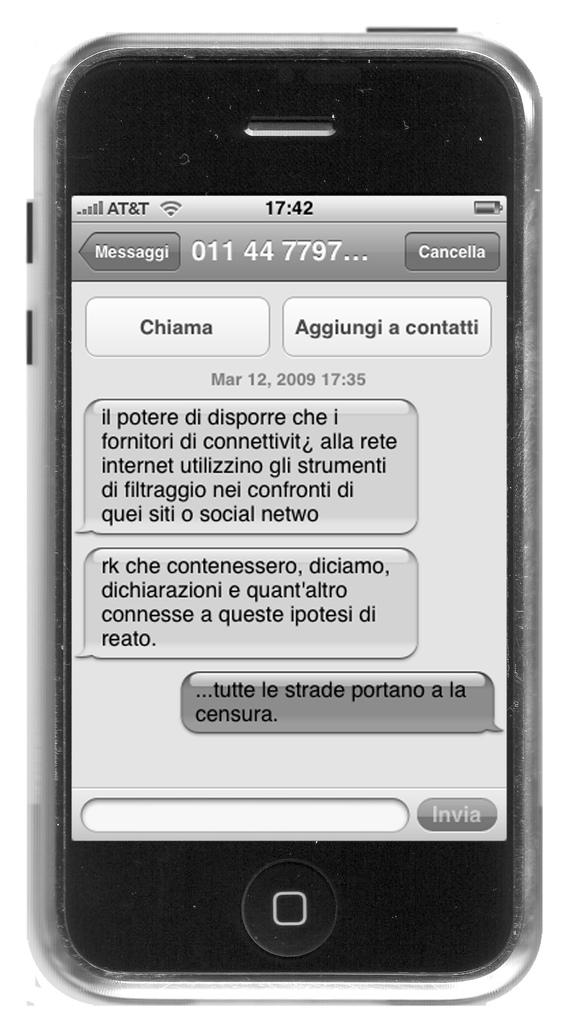<image>
Render a clear and concise summary of the photo. A phone with connected to AT&T has a text message pulled up on its screen. 